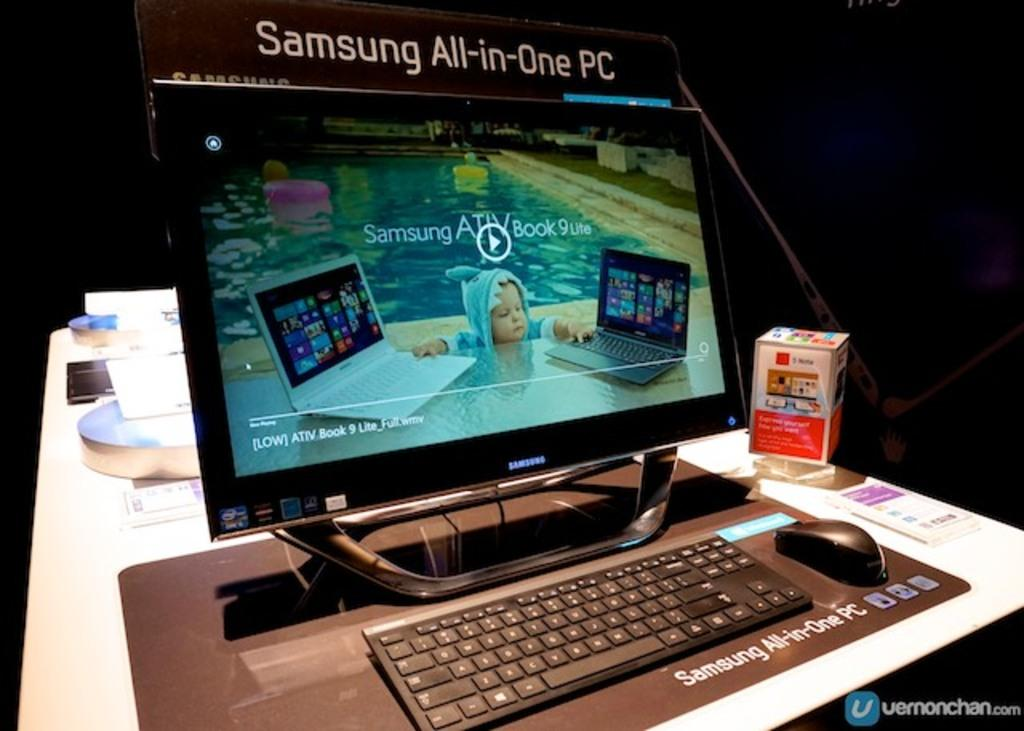What is the main electronic device in the image? There is a monitor in the image. What is placed in front of the monitor for input? There is a keyboard and a mouse in front of the monitor. What is located beside the monitor on the table? There is a box beside the monitor on a table. What else can be seen on the table behind the monitor? There are accessories on the table behind the monitor. Can you see any trouble skating on a cushion in the image? There is no reference to trouble, skating, or a cushion in the image. 